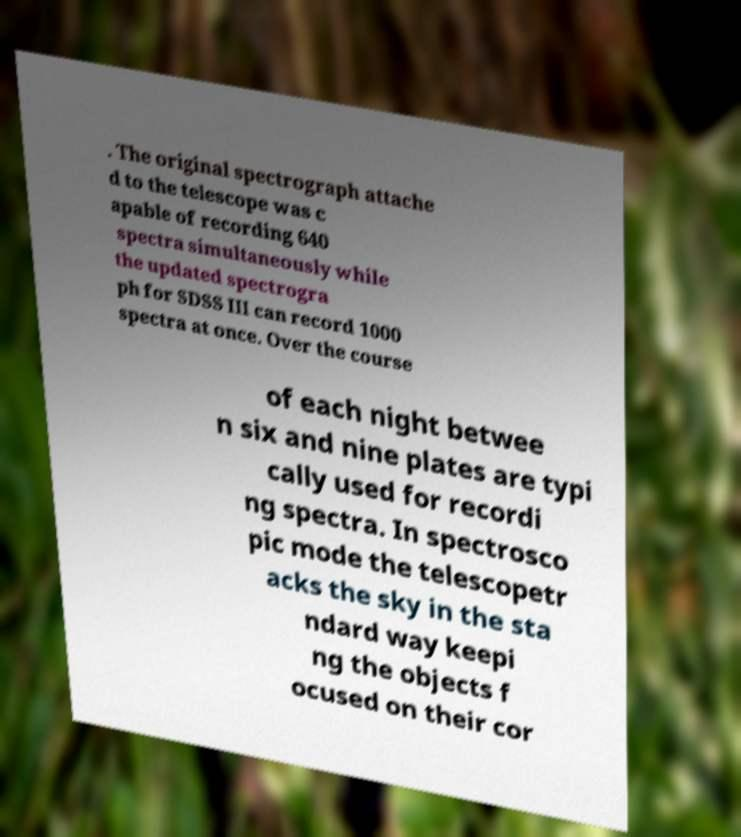Could you assist in decoding the text presented in this image and type it out clearly? . The original spectrograph attache d to the telescope was c apable of recording 640 spectra simultaneously while the updated spectrogra ph for SDSS III can record 1000 spectra at once. Over the course of each night betwee n six and nine plates are typi cally used for recordi ng spectra. In spectrosco pic mode the telescopetr acks the sky in the sta ndard way keepi ng the objects f ocused on their cor 